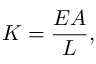Convert formula to latex. <formula><loc_0><loc_0><loc_500><loc_500>K = { \frac { E A } { L } } ,</formula> 